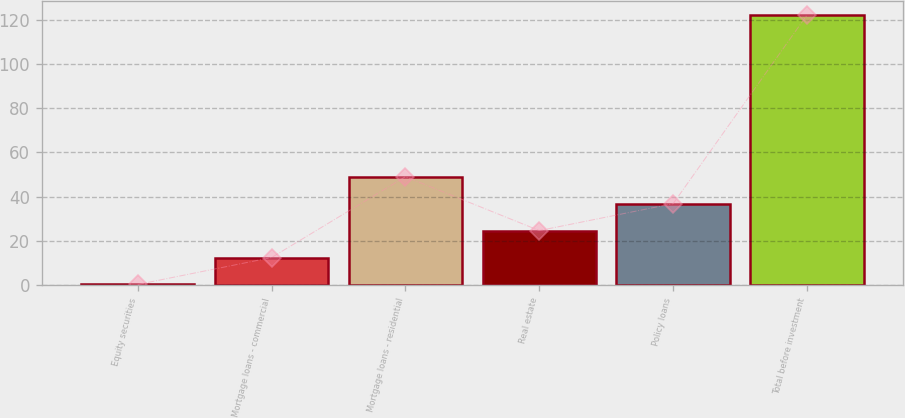<chart> <loc_0><loc_0><loc_500><loc_500><bar_chart><fcel>Equity securities<fcel>Mortgage loans - commercial<fcel>Mortgage loans - residential<fcel>Real estate<fcel>Policy loans<fcel>Total before investment<nl><fcel>0.3<fcel>12.49<fcel>49.06<fcel>24.68<fcel>36.87<fcel>122.2<nl></chart> 